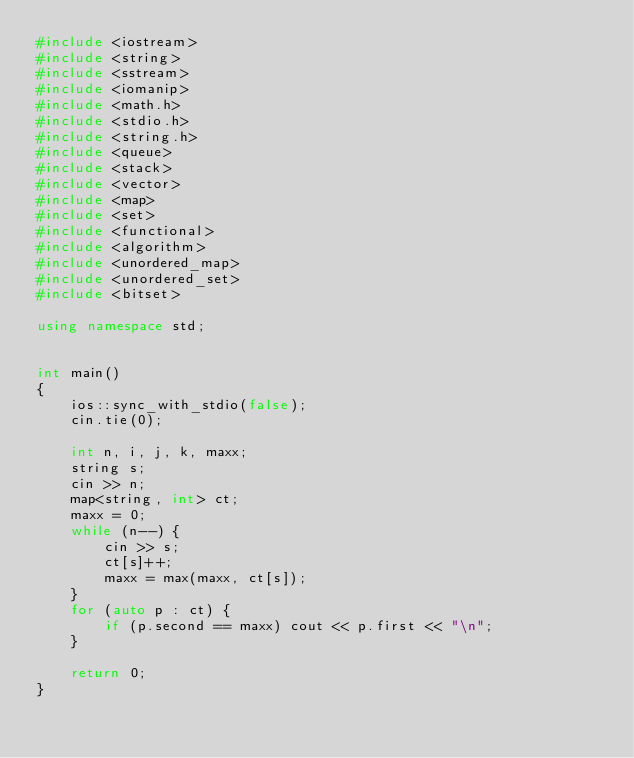Convert code to text. <code><loc_0><loc_0><loc_500><loc_500><_C++_>#include <iostream>
#include <string>
#include <sstream>
#include <iomanip> 
#include <math.h>
#include <stdio.h>
#include <string.h>
#include <queue>
#include <stack>
#include <vector>
#include <map>
#include <set>
#include <functional>
#include <algorithm>
#include <unordered_map>
#include <unordered_set>
#include <bitset>

using namespace std;


int main()
{
	ios::sync_with_stdio(false);
	cin.tie(0);

	int n, i, j, k, maxx;
	string s;
	cin >> n;
	map<string, int> ct;
	maxx = 0;
	while (n--) {
		cin >> s;
		ct[s]++;
		maxx = max(maxx, ct[s]);
	}
	for (auto p : ct) {
		if (p.second == maxx) cout << p.first << "\n";
	}

	return 0;
}
</code> 